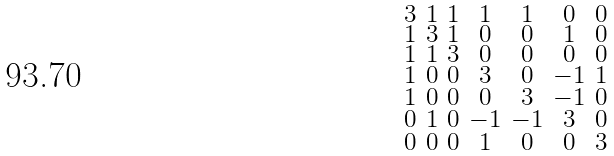Convert formula to latex. <formula><loc_0><loc_0><loc_500><loc_500>\begin{smallmatrix} 3 & 1 & 1 & 1 & 1 & 0 & 0 \\ 1 & 3 & 1 & 0 & 0 & 1 & 0 \\ 1 & 1 & 3 & 0 & 0 & 0 & 0 \\ 1 & 0 & 0 & 3 & 0 & - 1 & 1 \\ 1 & 0 & 0 & 0 & 3 & - 1 & 0 \\ 0 & 1 & 0 & - 1 & - 1 & 3 & 0 \\ 0 & 0 & 0 & 1 & 0 & 0 & 3 \end{smallmatrix}</formula> 